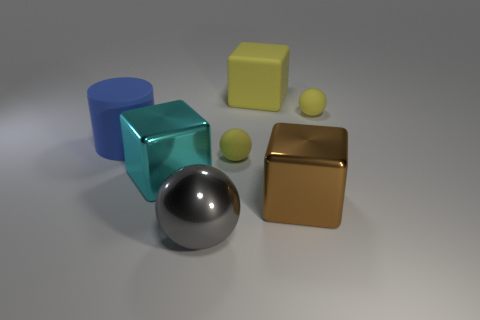Do the large yellow thing and the gray sphere have the same material?
Keep it short and to the point. No. There is a small yellow matte sphere that is to the left of the tiny yellow thing that is behind the large blue cylinder; are there any brown cubes behind it?
Offer a terse response. No. What number of other things are the same shape as the big cyan thing?
Your answer should be very brief. 2. There is a large thing that is both in front of the matte cylinder and on the right side of the big sphere; what shape is it?
Make the answer very short. Cube. What color is the large matte object that is right of the matte object left of the large metal thing that is left of the big ball?
Offer a very short reply. Yellow. Are there more cyan metallic objects in front of the cyan shiny cube than large spheres that are behind the gray metallic ball?
Your answer should be compact. No. How many other things are there of the same size as the brown metallic block?
Keep it short and to the point. 4. What material is the small object in front of the yellow object that is to the right of the large brown thing made of?
Offer a terse response. Rubber. Are there any gray metallic balls behind the blue matte object?
Offer a terse response. No. Is the number of large shiny balls that are on the right side of the big gray thing greater than the number of yellow cubes?
Your answer should be very brief. No. 